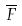Convert formula to latex. <formula><loc_0><loc_0><loc_500><loc_500>\overline { F }</formula> 